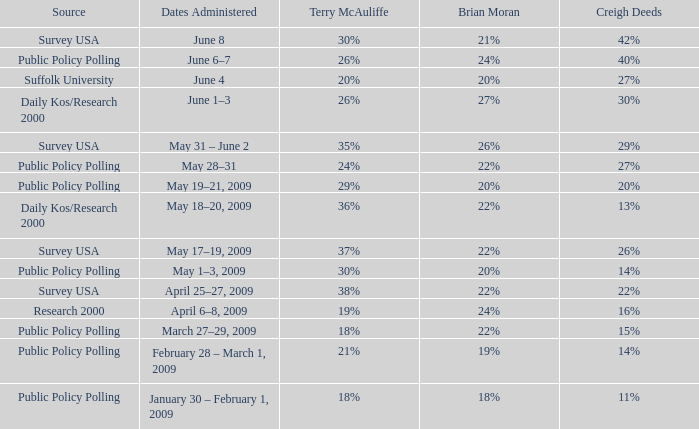Which Source has Terry McAuliffe of 36% Daily Kos/Research 2000. 